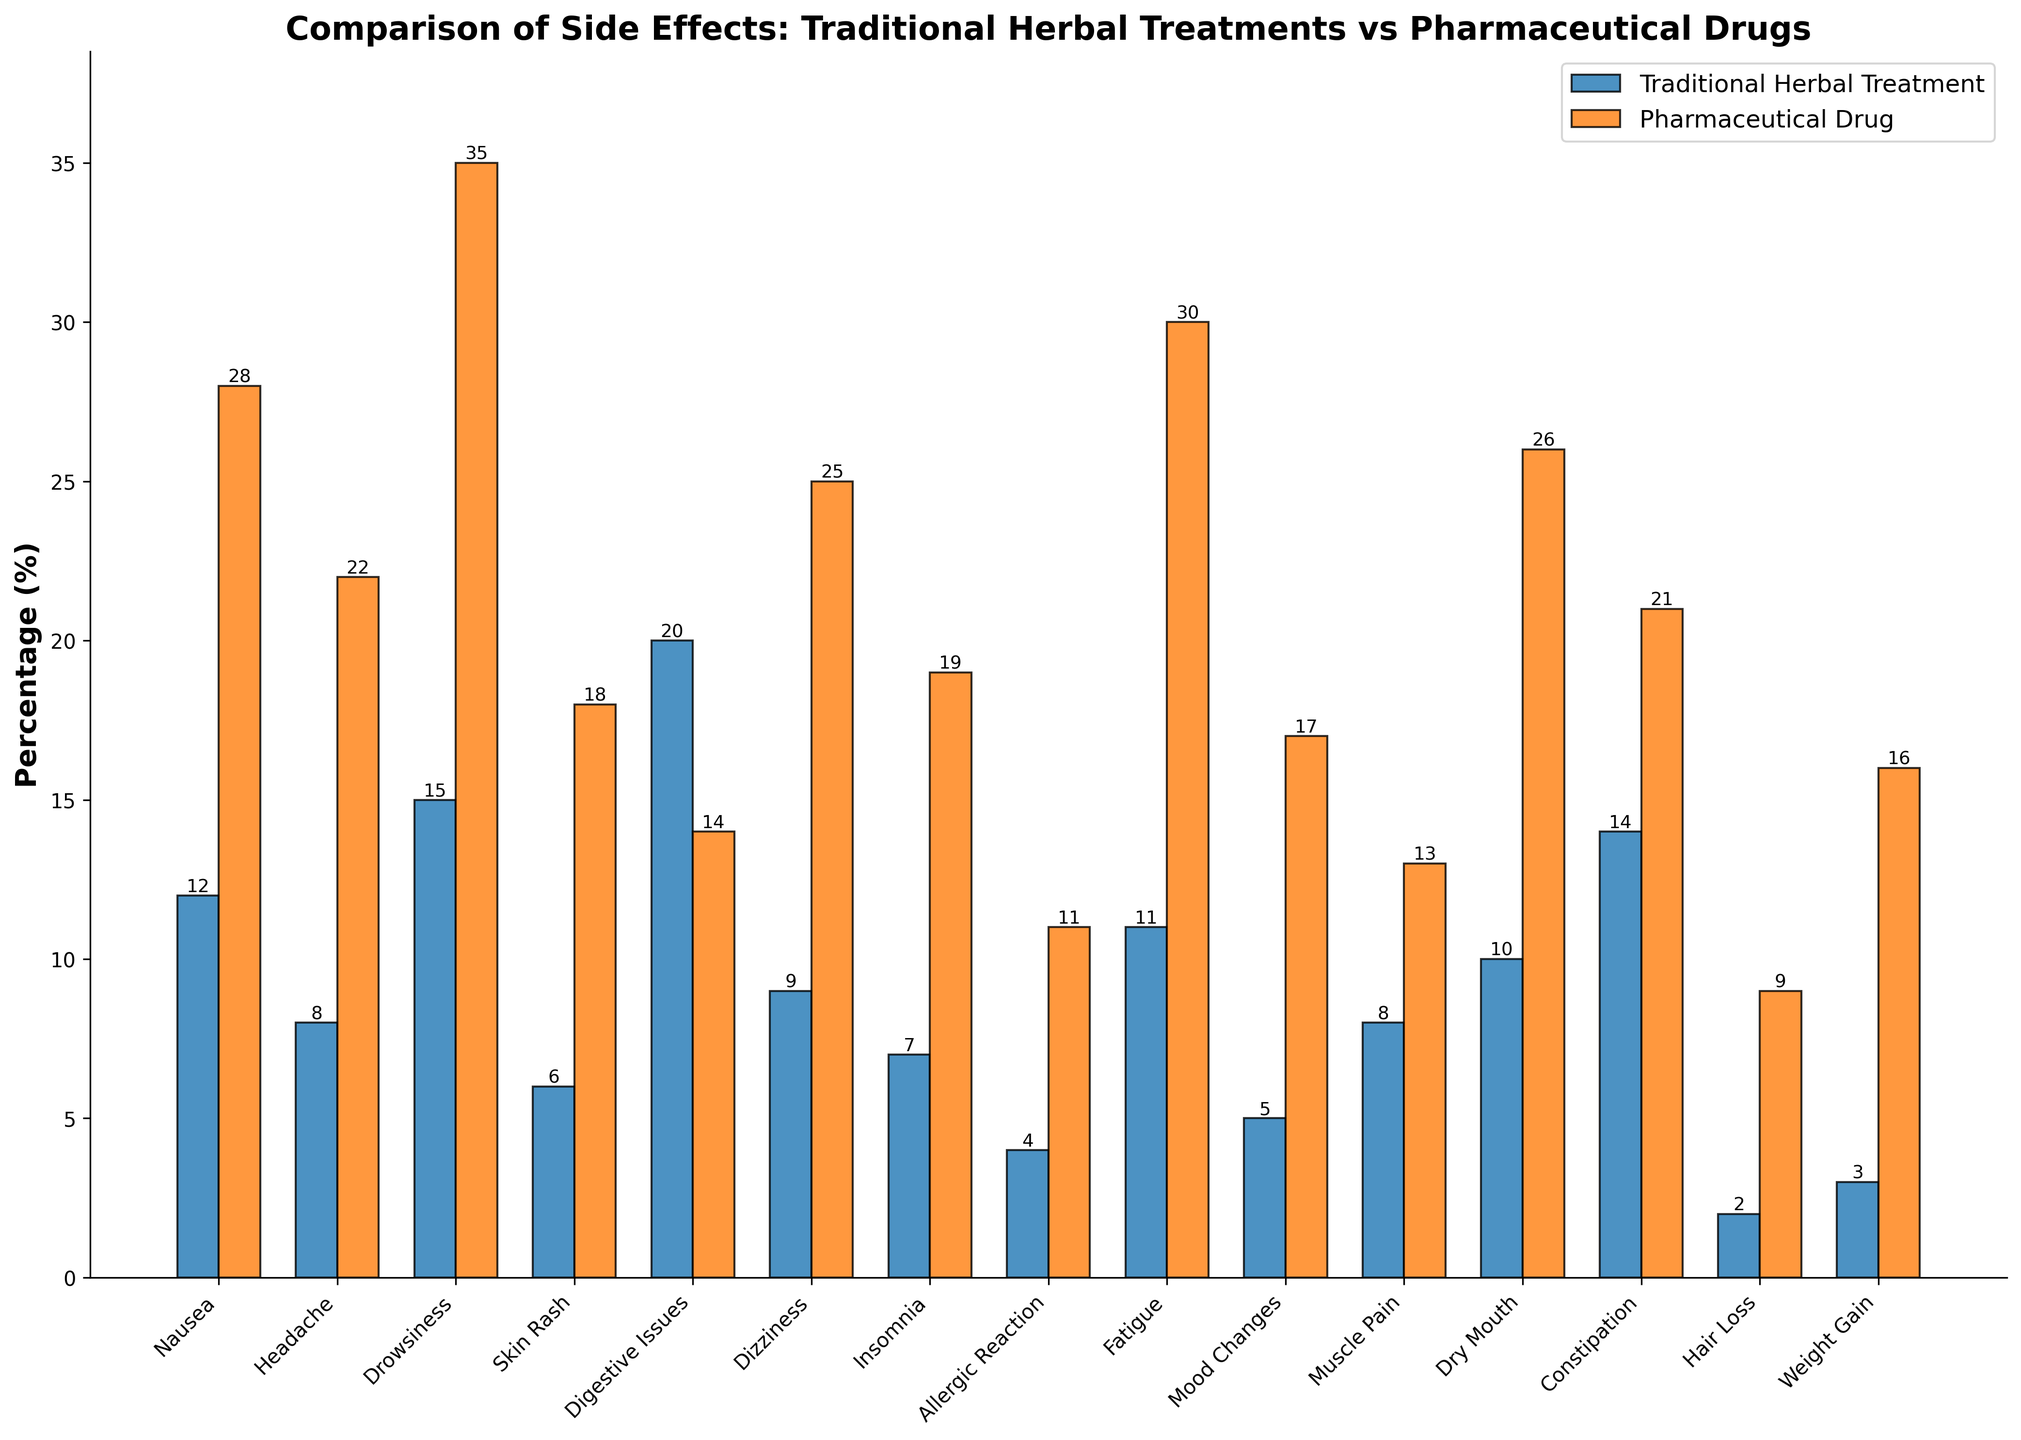What's the side effect with the highest percentage for pharmaceutical drugs? To find the side effect with the highest percentage for pharmaceutical drugs, look at the tallest orange bar. The tallest one corresponds to Drowsiness at 35%.
Answer: Drowsiness What is the difference in the percentage of nausea between traditional herbal treatments and pharmaceutical drugs? Find the percentage for nausea from both categories. Traditional herbal treatments have 12%, and pharmaceutical drugs have 28%. The difference is 28% - 12%.
Answer: 16% Which side effect has a higher percentage in traditional herbal treatments compared to pharmaceutical drugs? Compare each pair of bars between traditional herbal treatments and pharmaceutical drugs. Digestive Issues have a higher percentage in traditional herbal treatments (20%) compared to pharmaceutical drugs (14%).
Answer: Digestive Issues What is the average percentage of side effects for traditional herbal treatments? Add all the percentages for traditional herbal treatments and divide by the total number of side effects: (12 + 8 + 15 + 6 + 20 + 9 + 7 + 4 + 11 + 5 + 8 + 10 + 14 + 2 + 3) / 15.
Answer: 9.4% Is dizziness more common with traditional herbal treatments or pharmaceutical drugs? Compare the percentages for dizziness in both categories. Traditional herbal treatments have 9%, while pharmaceutical drugs have 25%. Thus, dizziness is more common with pharmaceutical drugs.
Answer: Pharmaceutical Drugs Which side effect has the closest percentage difference between traditional herbal treatments and pharmaceutical drugs? Look at the differences for each side effect between the two categories. Muscle Pain has the closest difference: Traditional Herbal Treatment (8%) and Pharmaceutical Drug (13%), a difference of 5%.
Answer: Muscle Pain How many side effects have a lower percentage in traditional herbal treatments compared to pharmaceutical drugs? Count the number of side effects where the blue bar (traditional herbal) is shorter than the orange bar (pharmaceutical drug): Nausea, Headache, Drowsiness, Skin Rash, Dizziness, Insomnia, Allergic Reaction, Fatigue, Mood Changes, Dry Mouth, Constipation, Hair Loss, and Weight Gain (13 side effects).
Answer: 13 What is the combined percentage of headache and fatigue for pharmaceutical drugs? Add the percentages for headache and fatigue under pharmaceutical drugs: 22% + 30% = 52%.
Answer: 52% Which side effect has the lowest percentage in traditional herbal treatments? Find the shortest blue bar in the figure, which corresponds to Hair Loss at 2%.
Answer: Hair Loss Between insomnia and skin rash, which side effect has a higher percentage for pharmaceutical drugs? Compare the percentages: Insomnia (19%) and Skin Rash (18%). Thus, insomnia has a slightly higher percentage for pharmaceutical drugs.
Answer: Insomnia 